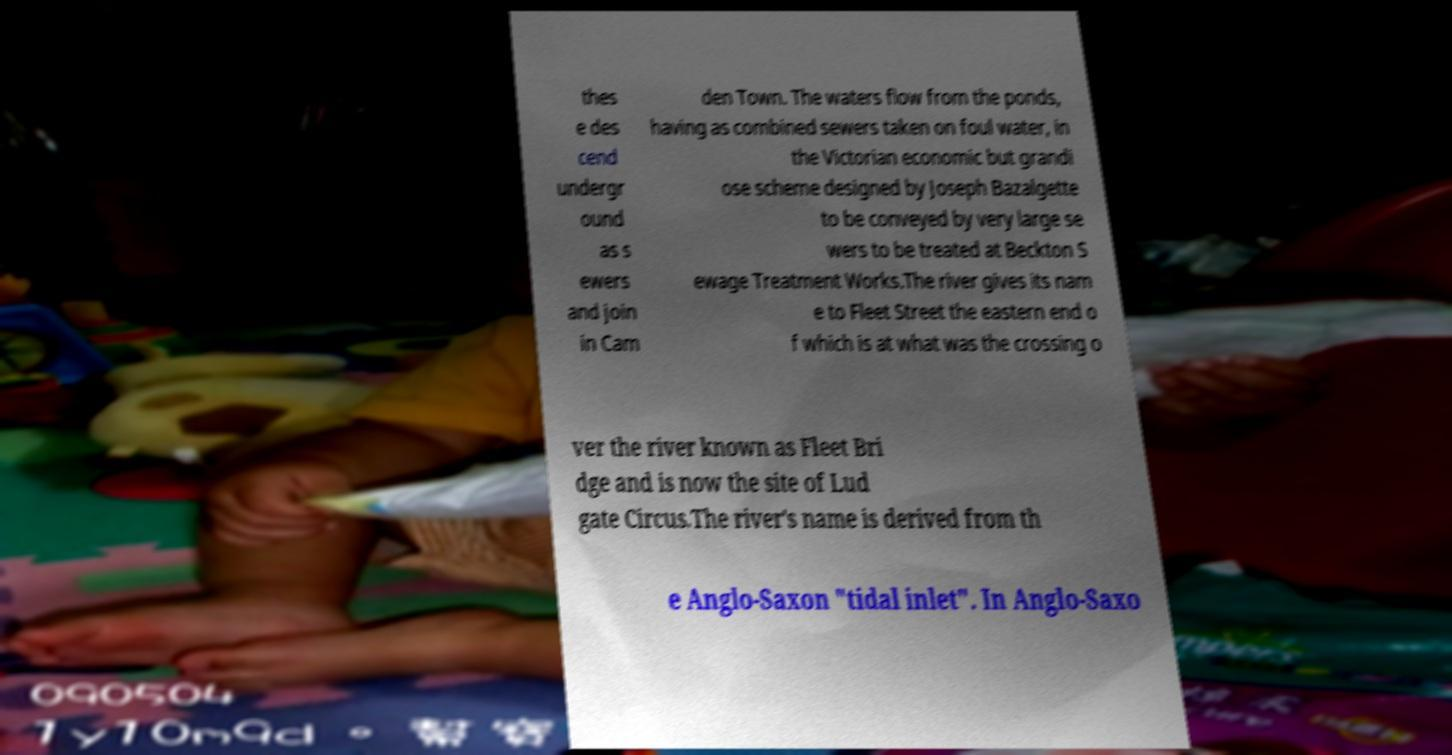For documentation purposes, I need the text within this image transcribed. Could you provide that? thes e des cend undergr ound as s ewers and join in Cam den Town. The waters flow from the ponds, having as combined sewers taken on foul water, in the Victorian economic but grandi ose scheme designed by Joseph Bazalgette to be conveyed by very large se wers to be treated at Beckton S ewage Treatment Works.The river gives its nam e to Fleet Street the eastern end o f which is at what was the crossing o ver the river known as Fleet Bri dge and is now the site of Lud gate Circus.The river's name is derived from th e Anglo-Saxon "tidal inlet". In Anglo-Saxo 